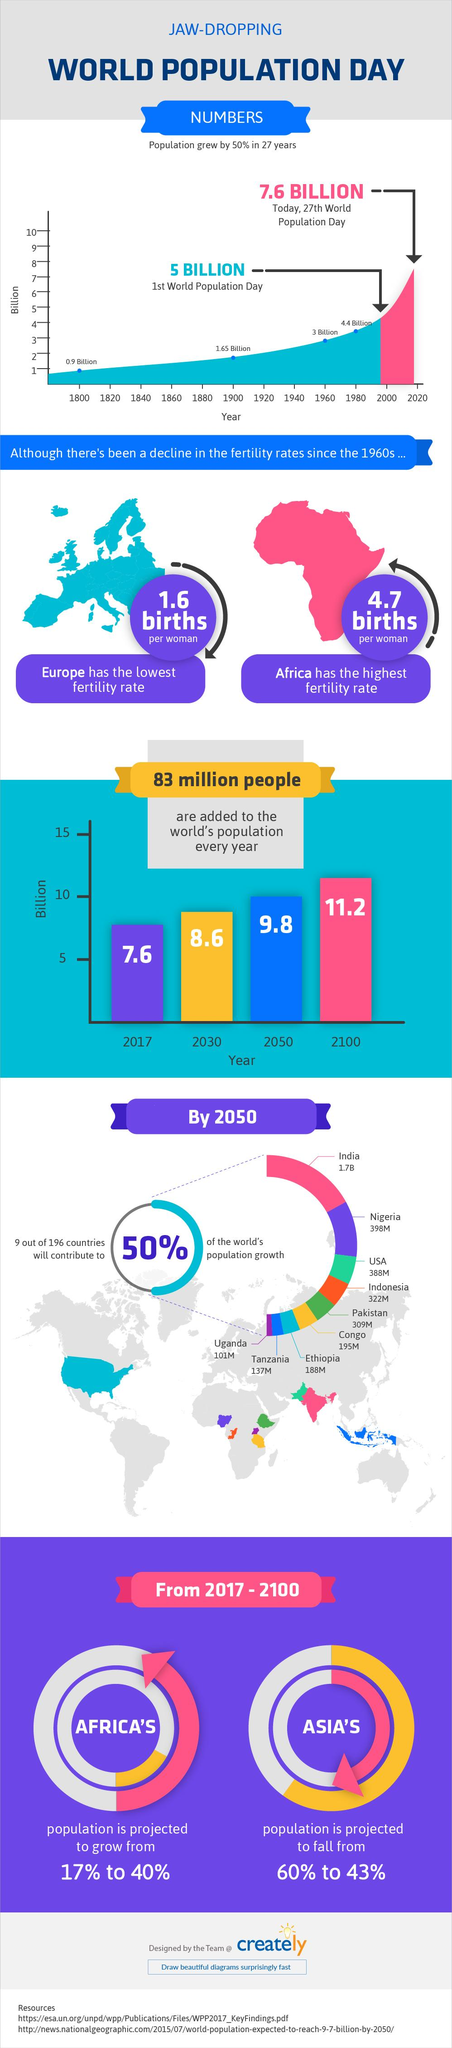Outline some significant characteristics in this image. By 2050, the population of Uganda and Tanzania taken together is projected to be approximately 238 million. According to estimates, the combined population of Nigeria and the United States of America is projected to be approximately 786 million by the year 2050. The population of Africa has increased by 23%. The population of Asia decreased by 17%. By 2050, the population of Ethiopia and Congo taken together is projected to be approximately 383 million. 